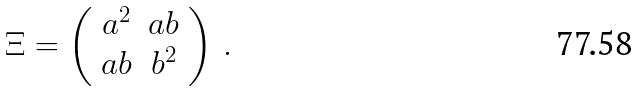<formula> <loc_0><loc_0><loc_500><loc_500>\Xi = \left ( \begin{array} { c c } { { a ^ { 2 } } } & { a b } \\ { a b } & { { b ^ { 2 } } } \end{array} \right ) \, .</formula> 